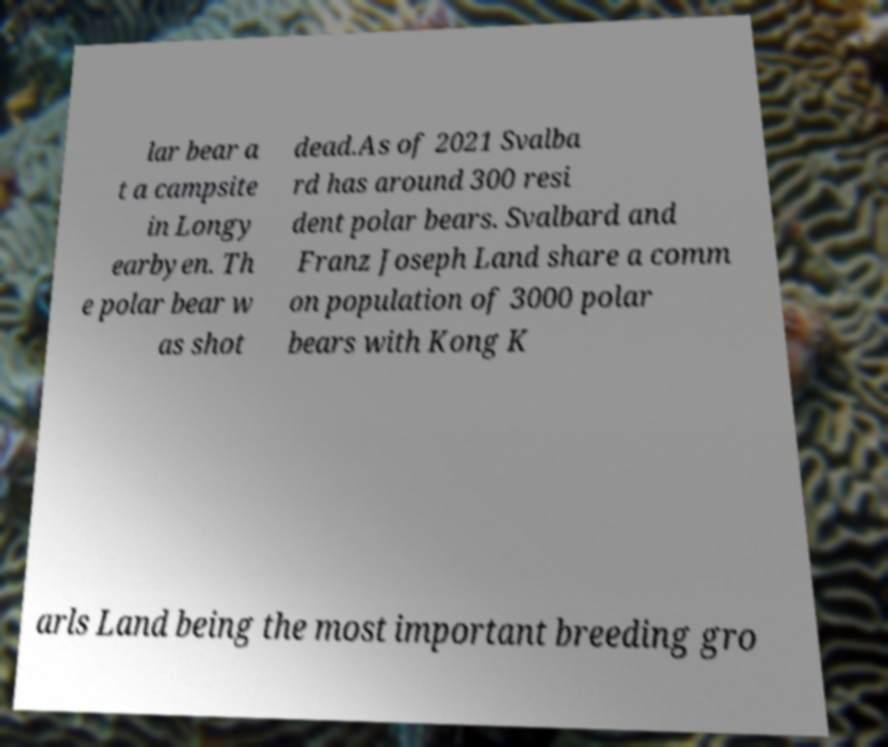There's text embedded in this image that I need extracted. Can you transcribe it verbatim? lar bear a t a campsite in Longy earbyen. Th e polar bear w as shot dead.As of 2021 Svalba rd has around 300 resi dent polar bears. Svalbard and Franz Joseph Land share a comm on population of 3000 polar bears with Kong K arls Land being the most important breeding gro 